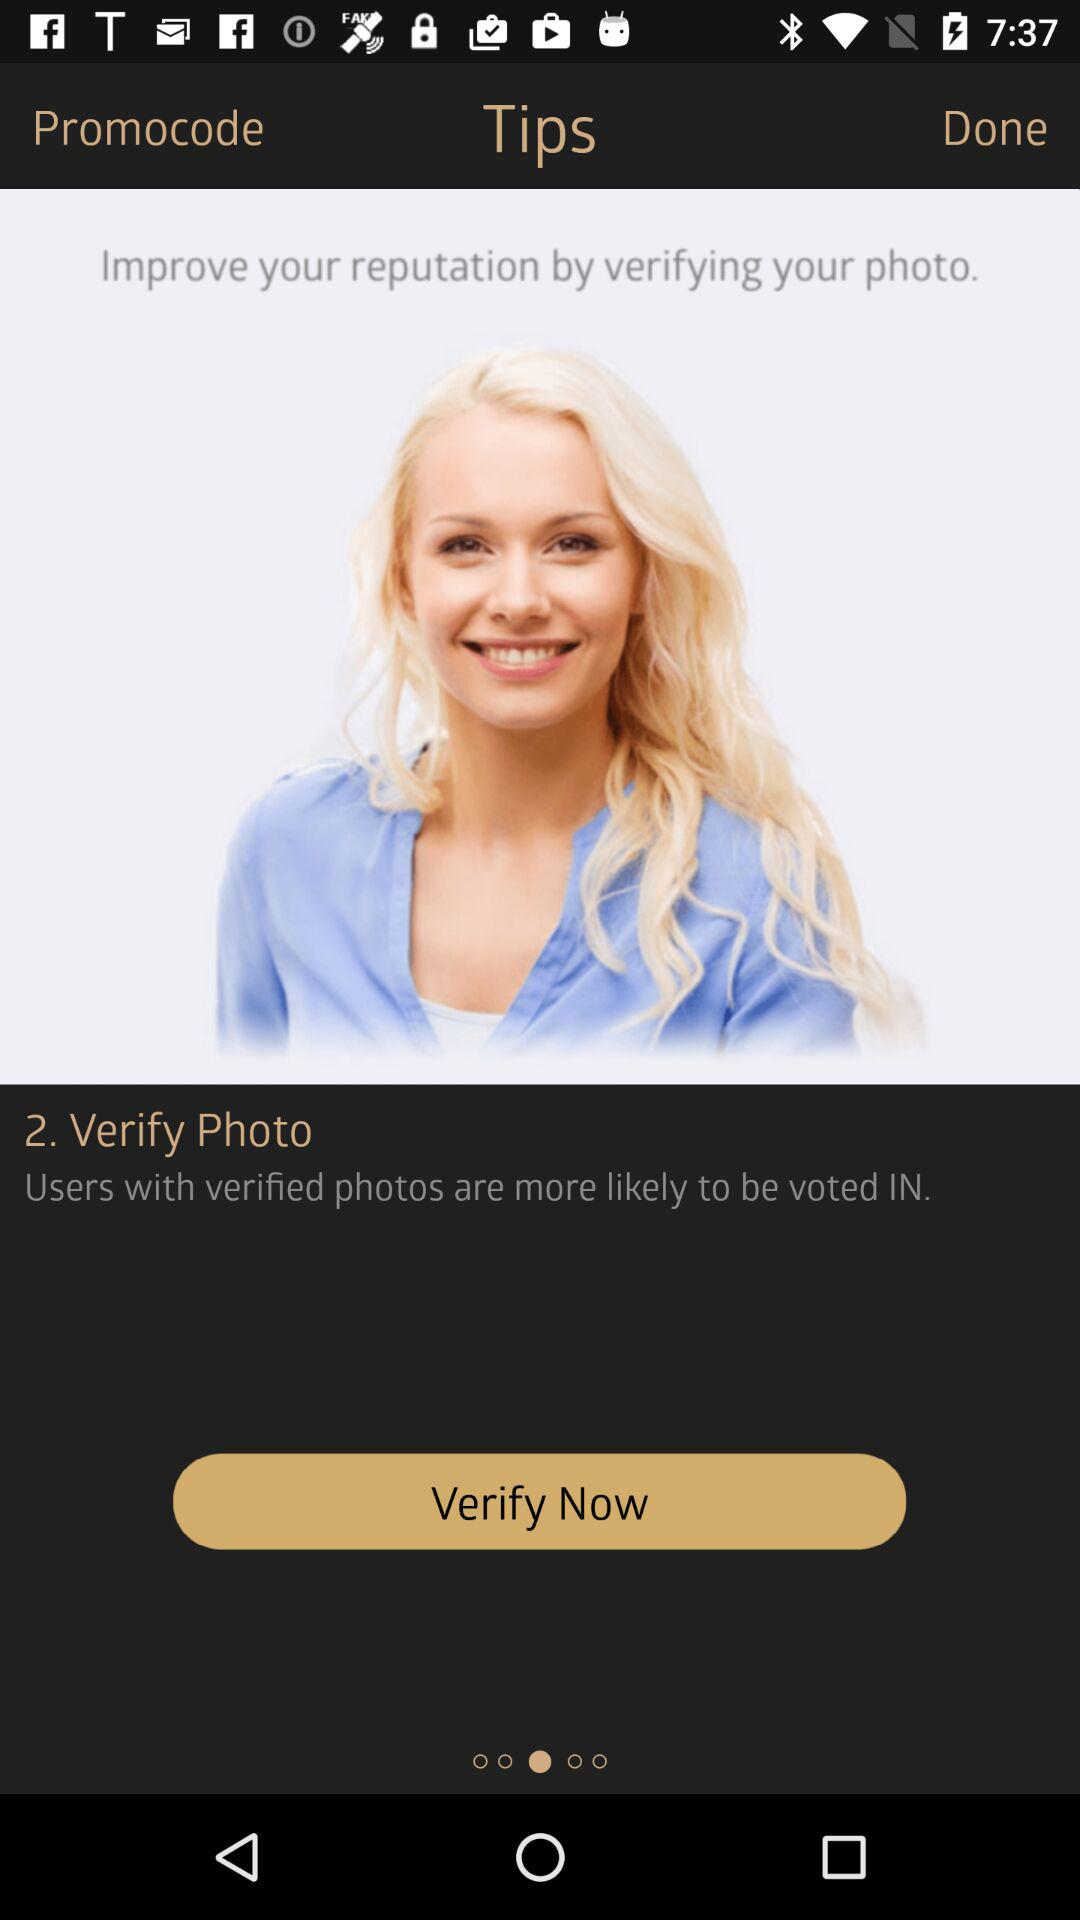How many steps are there before you can verify your photo?
Answer the question using a single word or phrase. 2 